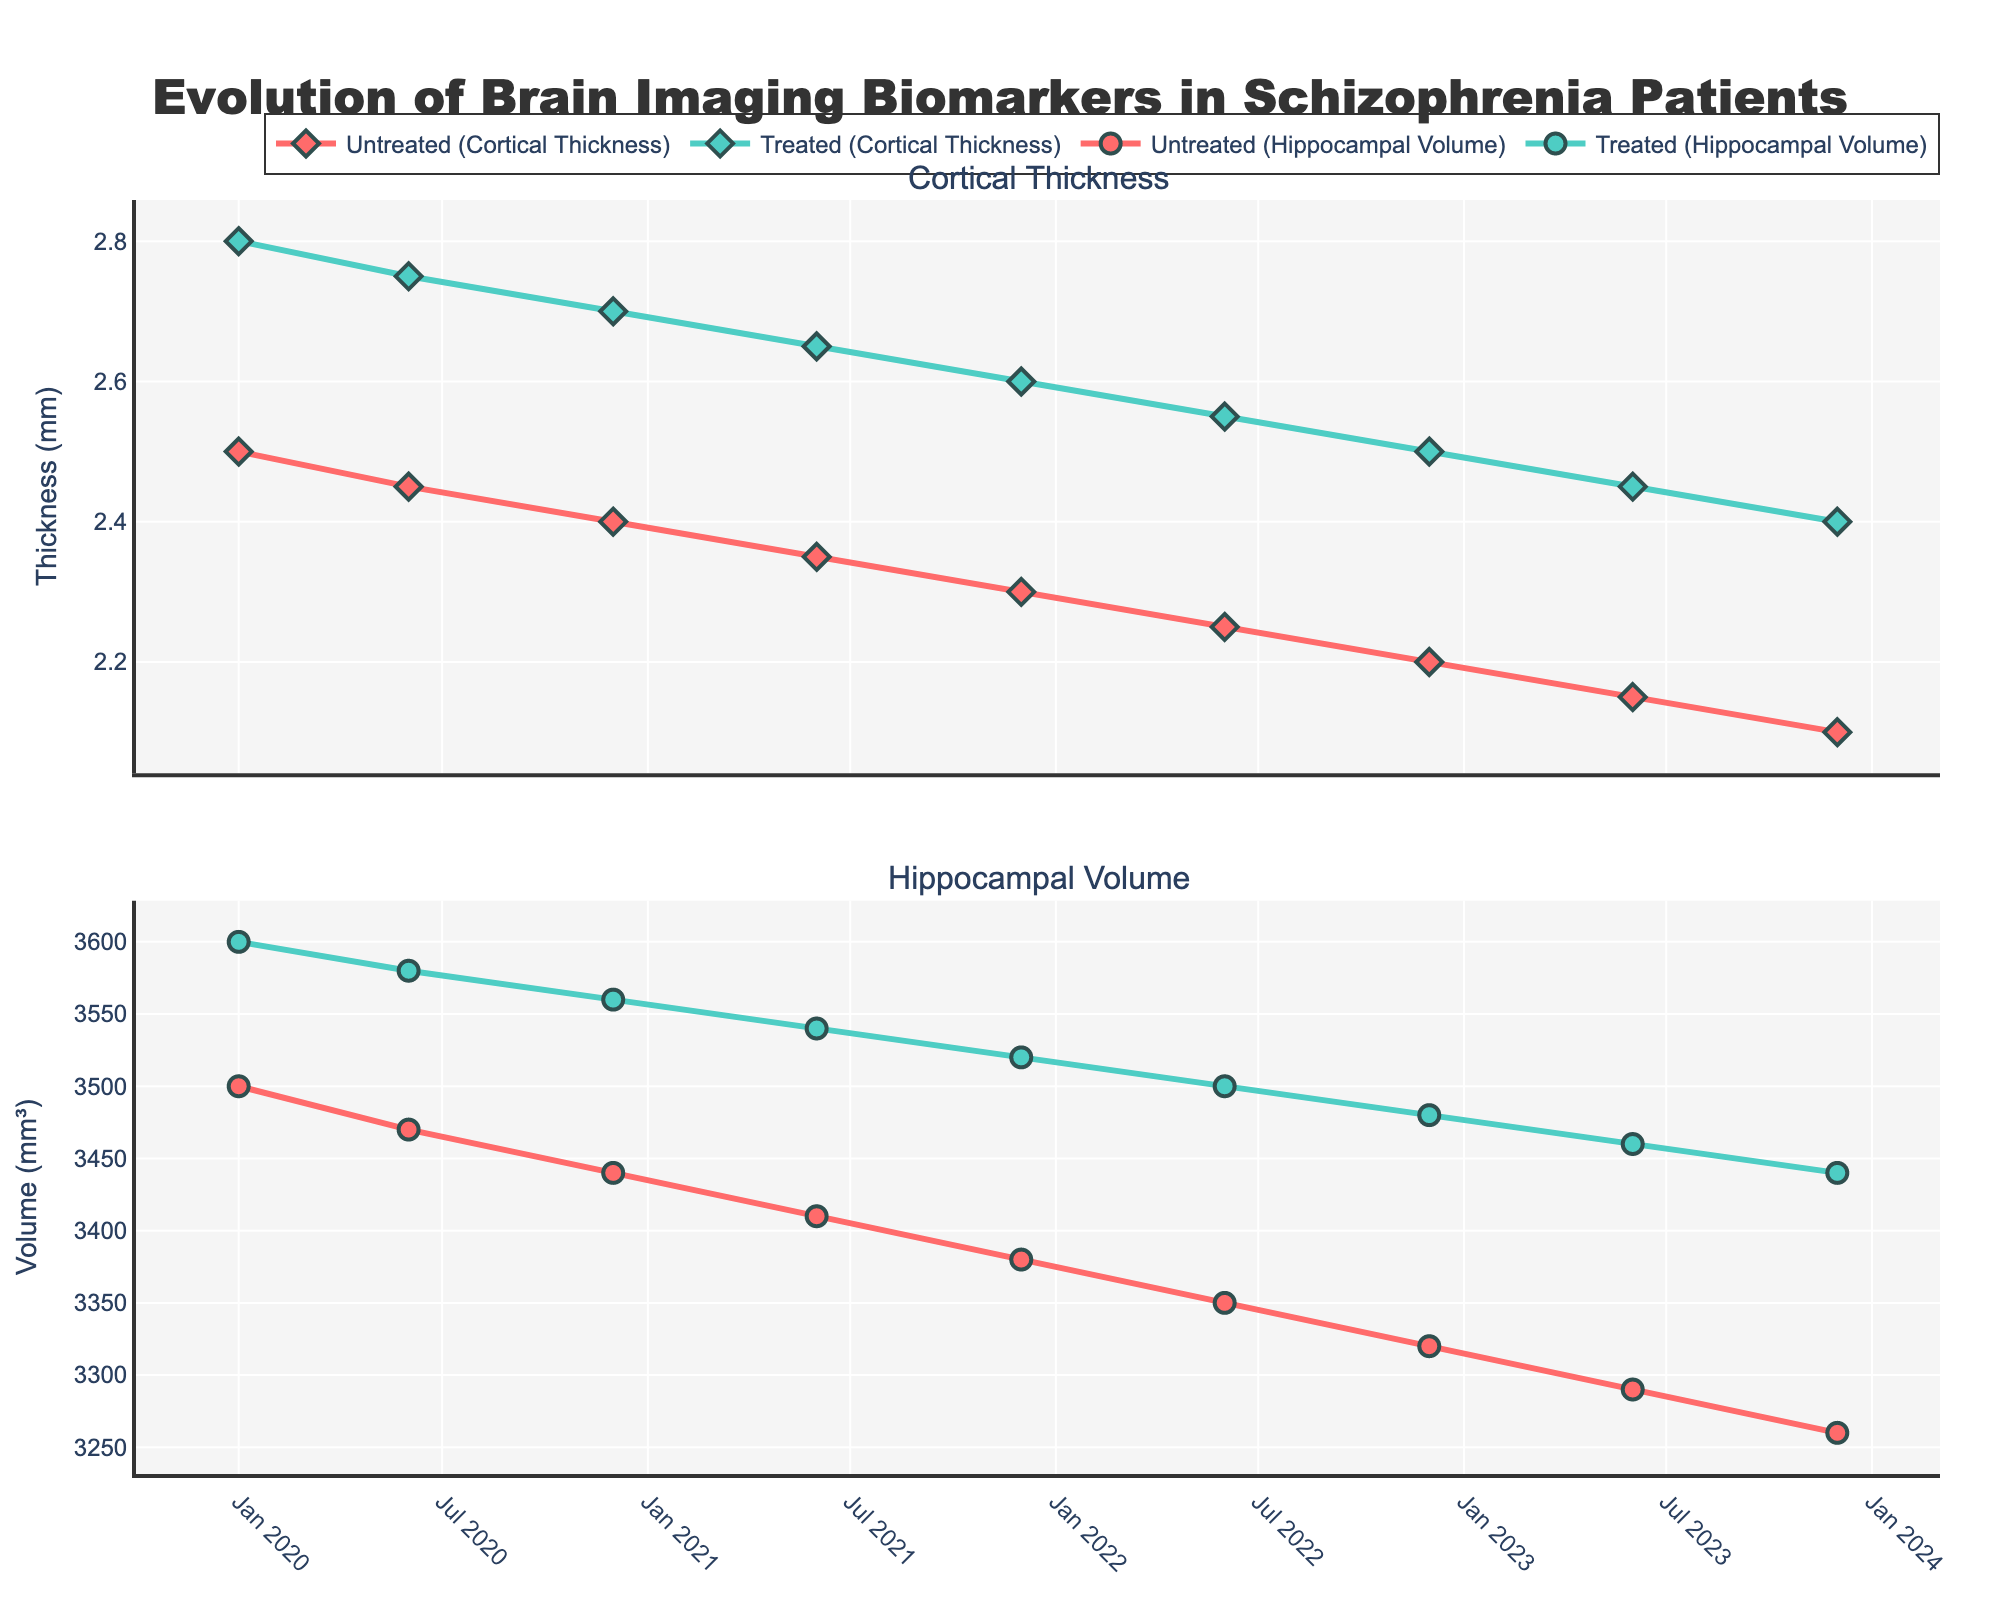How many different lines represent untreated schizophrenia patients? Look at the figure and count the lines corresponding to the untreated group for both biomarkers. Each group, untreated in this case, has two lines (one for cortical thickness and one for hippocampal volume).
Answer: 2 Which group starts with a higher cortical thickness in January 2020? Compare the cortical thickness values for both untreated and treated groups in January 2020. Untreated: 2.5 mm, Treated: 2.8 mm.
Answer: Treated What is the difference in hippocampal volume between treated and untreated patients in June 2022? Subtract the hippocampal volume of untreated patients (3350 mm³) from that of treated patients (3500 mm³) in June 2022. \(3500 - 3350 = 150\) mm³.
Answer: 150 mm³ How does the trend of hippocampal volume change over time for treated patients? Observe the line representing the hippocampal volume for treated patients. It starts high and consistently decreases over time (3600 mm³ in January 2020 to 3440 mm³ in December 2023).
Answer: Decreasing Which group shows a more rapid decline in cortical thickness over the period? Analyze the slopes of the cortical thickness lines for both groups from January 2020 to December 2023. Untreated: 2.5 mm to 2.1 mm, Treated: 2.8 mm to 2.4 mm. Although both decline, untreated patients show a steeper decline.
Answer: Untreated What is the overall decrease in cortical thickness for untreated patients from January 2020 to December 2023? Subtract the cortical thickness in December 2023 (2.1 mm) from that in January 2020 (2.5 mm). \(2.5 - 2.1 = 0.4\) mm.
Answer: 0.4 mm At which time point is the difference in cortical thickness between treated and untreated patients the greatest? Compare the differences at each time point. The maximum difference is 0.4 mm, occurring in January 2020, June 2020, and December 2020 (2.8 - 2.4 mm = 0.4).
Answer: January 2020, June 2020, December 2020 What is the average hippocampal volume for treated patients across all time points? Sum the hippocampal volumes at each time point and divide by the number of time points: \( (3600 + 3580 + 3560 + 3540 + 3520 + 3500 + 3480 + 3460 + 3440) / 9 = 3514.4 \) mm³.
Answer: 3514.4 mm³ How does the trend of cortical thickness compare between the two groups over the entire duration? Compare the slopes of the cortical thickness lines for untreated and treated groups from January 2020 to December 2023. Both decline, but the untreated group has a steeper slope, indicating a more rapid decline.
Answer: Both decline, untreated declines faster 